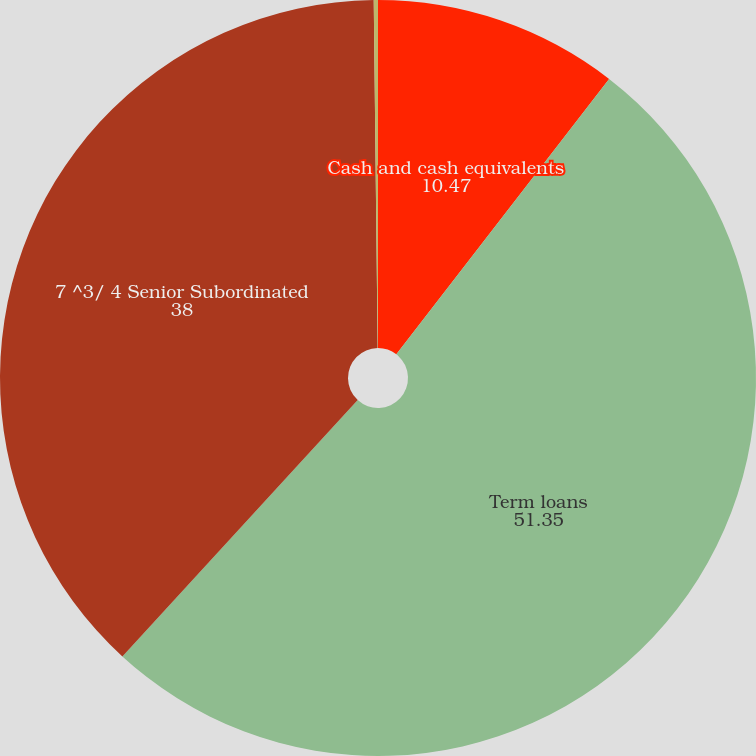Convert chart to OTSL. <chart><loc_0><loc_0><loc_500><loc_500><pie_chart><fcel>Cash and cash equivalents<fcel>Term loans<fcel>7 ^3/ 4 Senior Subordinated<fcel>Interest rate swap (2)<nl><fcel>10.47%<fcel>51.35%<fcel>38.0%<fcel>0.18%<nl></chart> 